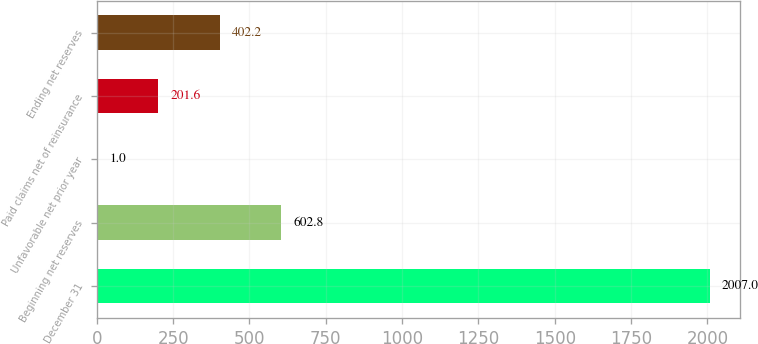Convert chart. <chart><loc_0><loc_0><loc_500><loc_500><bar_chart><fcel>December 31<fcel>Beginning net reserves<fcel>Unfavorable net prior year<fcel>Paid claims net of reinsurance<fcel>Ending net reserves<nl><fcel>2007<fcel>602.8<fcel>1<fcel>201.6<fcel>402.2<nl></chart> 